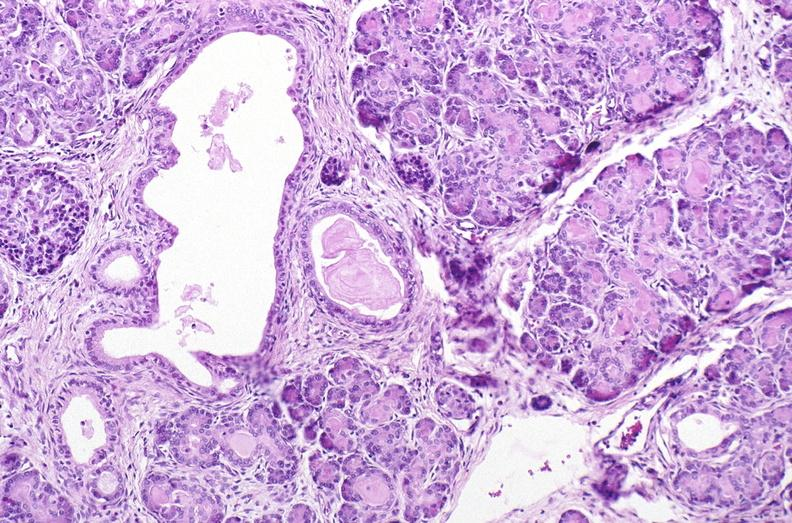what does this image show?
Answer the question using a single word or phrase. Cystic fibrosis 